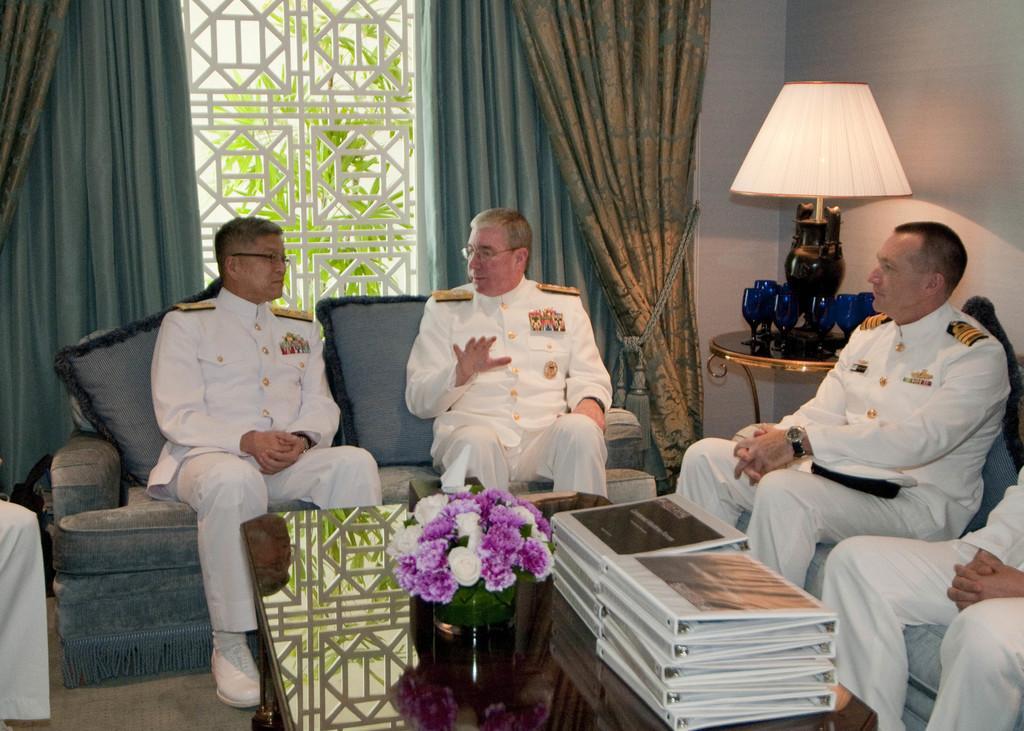Please provide a concise description of this image. In this image i can see there are few men who are sitting on a sofa in front of a table. On the table we have a flower pot and other objects on it. 